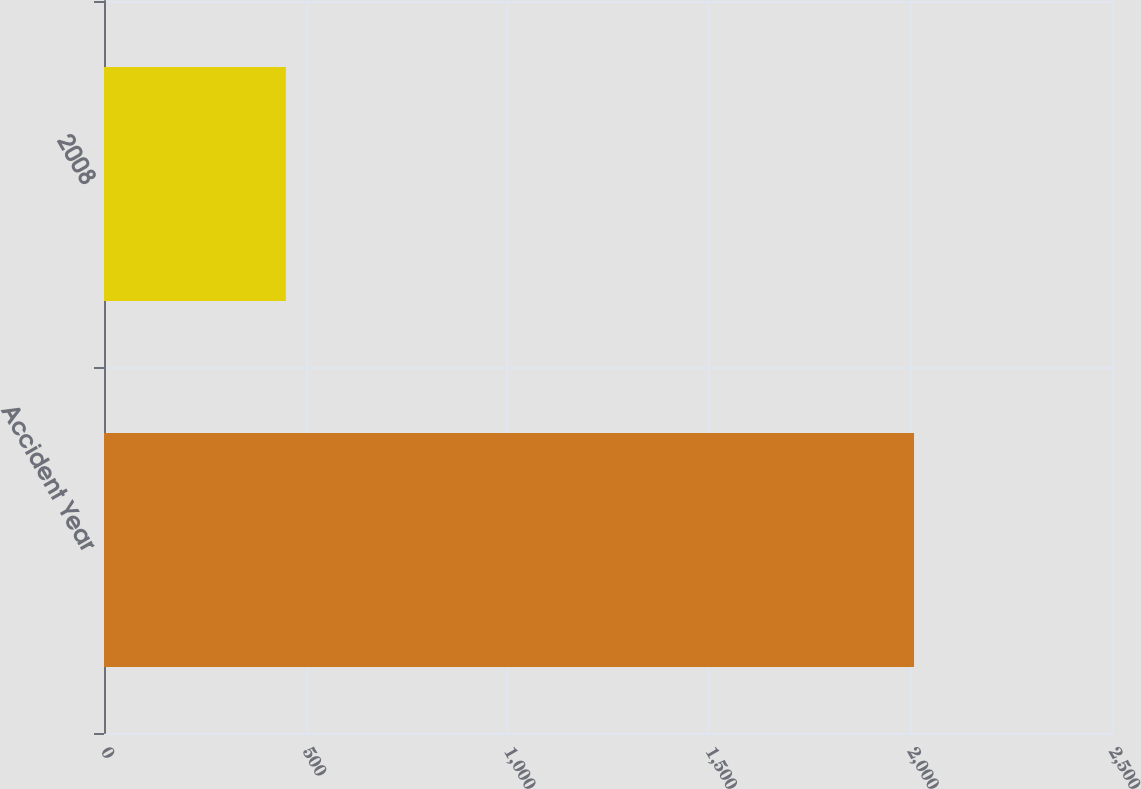Convert chart. <chart><loc_0><loc_0><loc_500><loc_500><bar_chart><fcel>Accident Year<fcel>2008<nl><fcel>2009<fcel>451<nl></chart> 